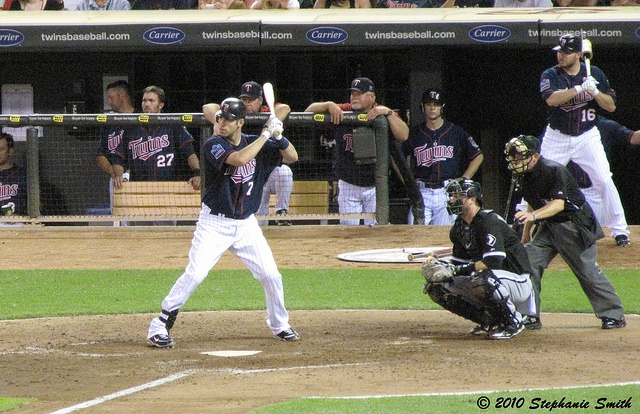Describe the objects in this image and their specific colors. I can see people in lightgray, lavender, black, gray, and darkgray tones, people in lightgray, black, gray, and darkgray tones, people in lightgray, black, gray, tan, and darkgray tones, people in lightgray, lavender, black, and gray tones, and people in lightgray, black, gray, and darkgray tones in this image. 